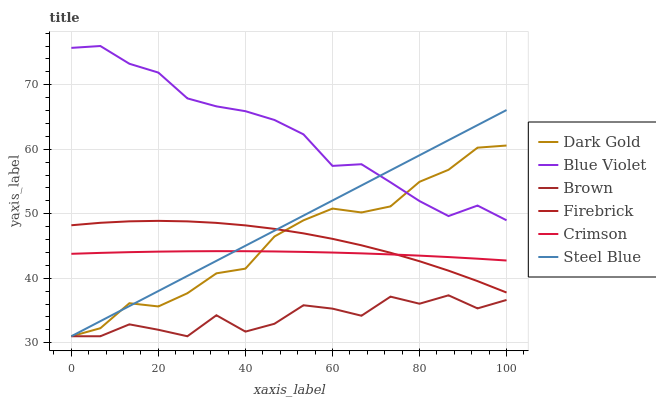Does Brown have the minimum area under the curve?
Answer yes or no. Yes. Does Blue Violet have the maximum area under the curve?
Answer yes or no. Yes. Does Dark Gold have the minimum area under the curve?
Answer yes or no. No. Does Dark Gold have the maximum area under the curve?
Answer yes or no. No. Is Steel Blue the smoothest?
Answer yes or no. Yes. Is Brown the roughest?
Answer yes or no. Yes. Is Dark Gold the smoothest?
Answer yes or no. No. Is Dark Gold the roughest?
Answer yes or no. No. Does Firebrick have the lowest value?
Answer yes or no. No. Does Blue Violet have the highest value?
Answer yes or no. Yes. Does Dark Gold have the highest value?
Answer yes or no. No. Is Brown less than Firebrick?
Answer yes or no. Yes. Is Firebrick greater than Brown?
Answer yes or no. Yes. Does Brown intersect Firebrick?
Answer yes or no. No. 